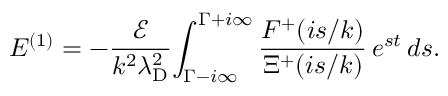Convert formula to latex. <formula><loc_0><loc_0><loc_500><loc_500>E ^ { ( 1 ) } = - \frac { \mathcal { E } } { k ^ { 2 } \lambda _ { D } ^ { 2 } } \, \int _ { \Gamma - i \infty } ^ { \Gamma + i \infty } \frac { F ^ { + } ( i s / k ) } { \Xi ^ { + } ( i s / k ) } \, e ^ { s t } \, d s .</formula> 